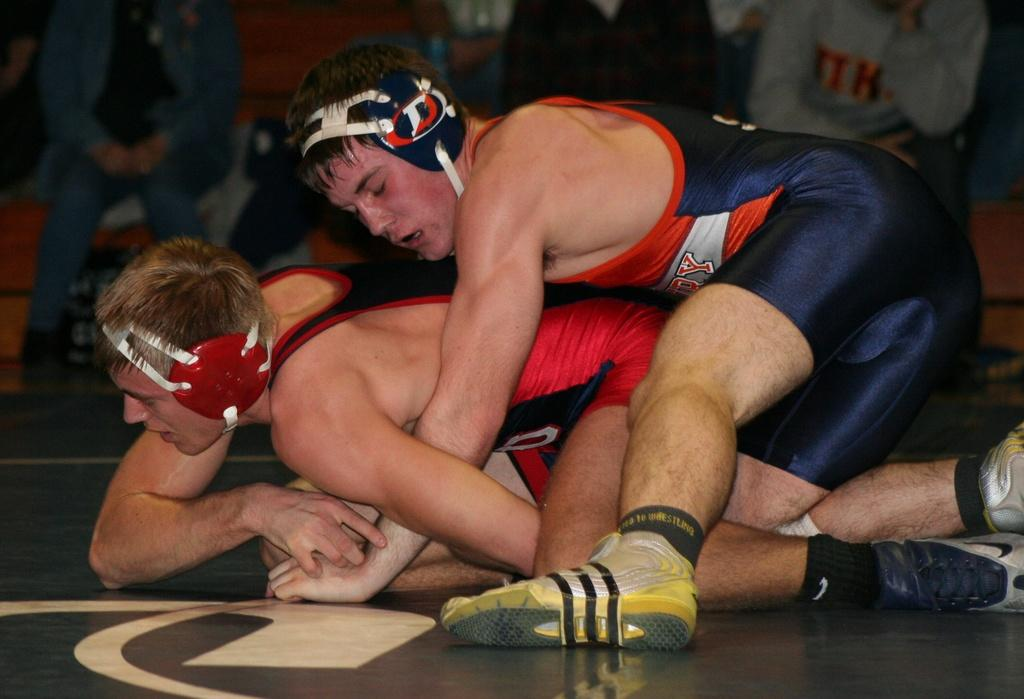How many people are visible in the image? There are two people in the foreground of the image, and many people in the background of the image. Can you describe the people in the foreground? Unfortunately, the facts provided do not give any specific details about the people in the foreground. What is the general setting of the image? The facts provided do not give any specific details about the setting of the image. What type of mist can be seen surrounding the creator in the image? There is no mention of a creator or mist in the image, so this question cannot be answered. 